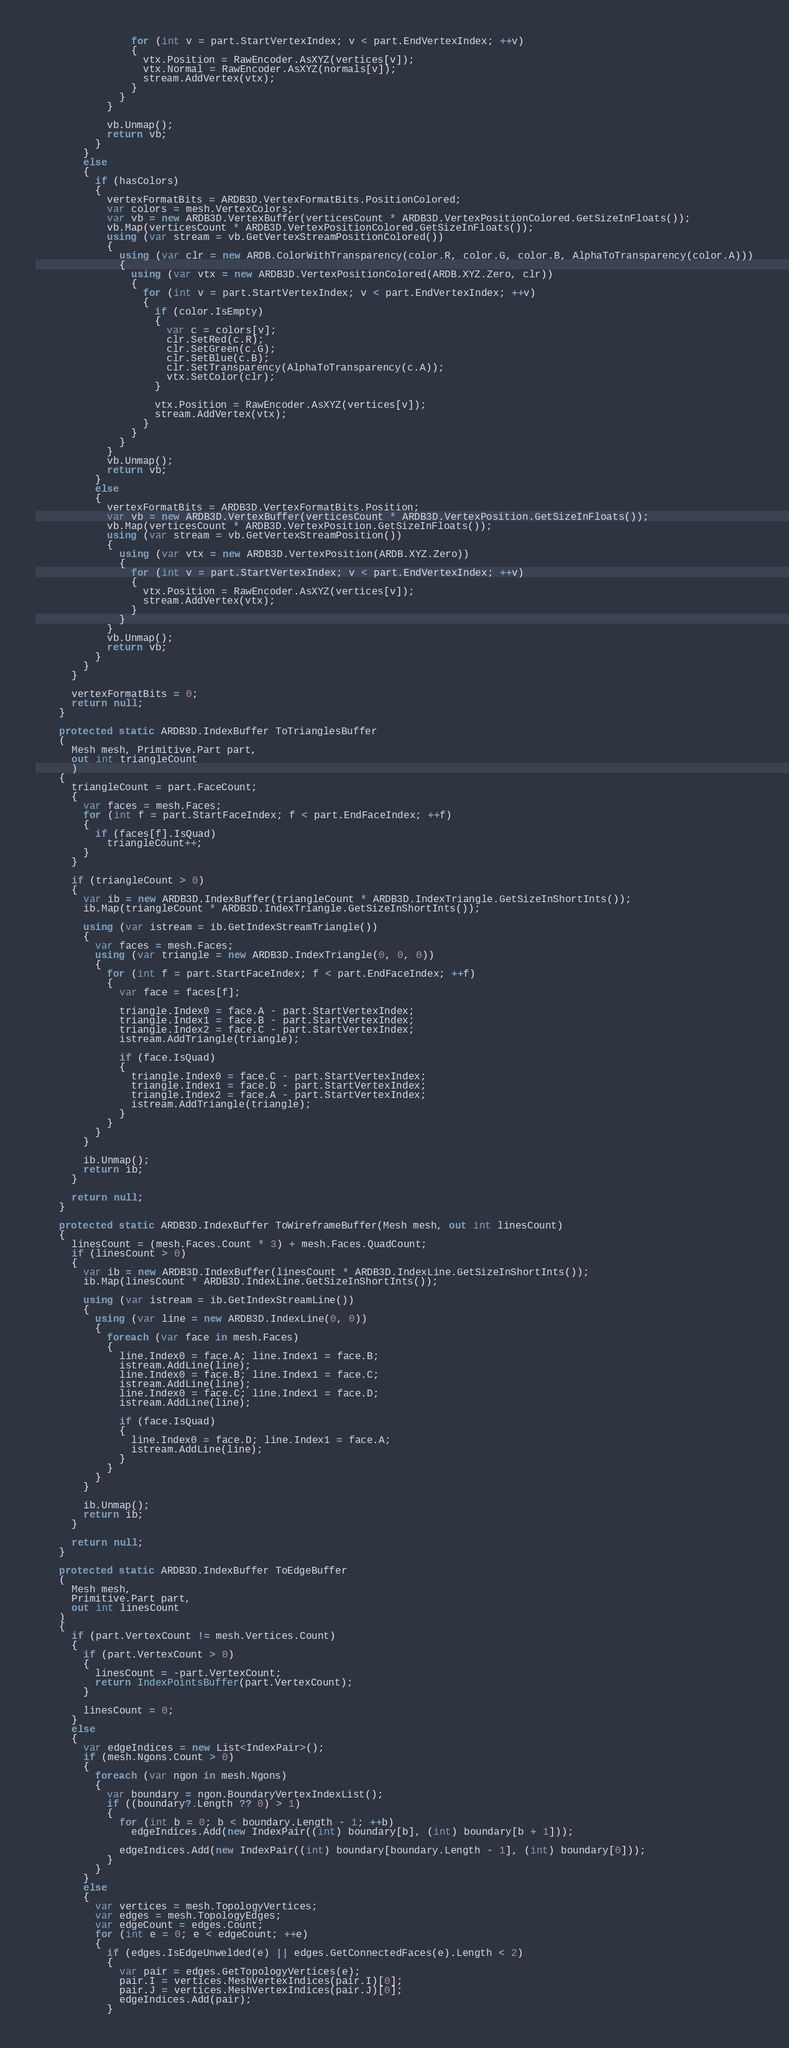<code> <loc_0><loc_0><loc_500><loc_500><_C#_>                for (int v = part.StartVertexIndex; v < part.EndVertexIndex; ++v)
                {
                  vtx.Position = RawEncoder.AsXYZ(vertices[v]);
                  vtx.Normal = RawEncoder.AsXYZ(normals[v]);
                  stream.AddVertex(vtx);
                }
              }
            }

            vb.Unmap();
            return vb;
          }
        }
        else
        {
          if (hasColors)
          {
            vertexFormatBits = ARDB3D.VertexFormatBits.PositionColored;
            var colors = mesh.VertexColors;
            var vb = new ARDB3D.VertexBuffer(verticesCount * ARDB3D.VertexPositionColored.GetSizeInFloats());
            vb.Map(verticesCount * ARDB3D.VertexPositionColored.GetSizeInFloats());
            using (var stream = vb.GetVertexStreamPositionColored())
            {
              using (var clr = new ARDB.ColorWithTransparency(color.R, color.G, color.B, AlphaToTransparency(color.A)))
              {
                using (var vtx = new ARDB3D.VertexPositionColored(ARDB.XYZ.Zero, clr))
                {
                  for (int v = part.StartVertexIndex; v < part.EndVertexIndex; ++v)
                  {
                    if (color.IsEmpty)
                    {
                      var c = colors[v];
                      clr.SetRed(c.R);
                      clr.SetGreen(c.G);
                      clr.SetBlue(c.B);
                      clr.SetTransparency(AlphaToTransparency(c.A));
                      vtx.SetColor(clr);
                    }

                    vtx.Position = RawEncoder.AsXYZ(vertices[v]);
                    stream.AddVertex(vtx);
                  }
                }
              }
            }
            vb.Unmap();
            return vb;
          }
          else
          {
            vertexFormatBits = ARDB3D.VertexFormatBits.Position;
            var vb = new ARDB3D.VertexBuffer(verticesCount * ARDB3D.VertexPosition.GetSizeInFloats());
            vb.Map(verticesCount * ARDB3D.VertexPosition.GetSizeInFloats());
            using (var stream = vb.GetVertexStreamPosition())
            {
              using (var vtx = new ARDB3D.VertexPosition(ARDB.XYZ.Zero))
              {
                for (int v = part.StartVertexIndex; v < part.EndVertexIndex; ++v)
                {
                  vtx.Position = RawEncoder.AsXYZ(vertices[v]);
                  stream.AddVertex(vtx);
                }
              }
            }
            vb.Unmap();
            return vb;
          }
        }
      }

      vertexFormatBits = 0;
      return null;
    }

    protected static ARDB3D.IndexBuffer ToTrianglesBuffer
    (
      Mesh mesh, Primitive.Part part,
      out int triangleCount
      )
    {
      triangleCount = part.FaceCount;
      {
        var faces = mesh.Faces;
        for (int f = part.StartFaceIndex; f < part.EndFaceIndex; ++f)
        {
          if (faces[f].IsQuad)
            triangleCount++;
        }
      }

      if (triangleCount > 0)
      {
        var ib = new ARDB3D.IndexBuffer(triangleCount * ARDB3D.IndexTriangle.GetSizeInShortInts());
        ib.Map(triangleCount * ARDB3D.IndexTriangle.GetSizeInShortInts());

        using (var istream = ib.GetIndexStreamTriangle())
        {
          var faces = mesh.Faces;
          using (var triangle = new ARDB3D.IndexTriangle(0, 0, 0))
          {
            for (int f = part.StartFaceIndex; f < part.EndFaceIndex; ++f)
            {
              var face = faces[f];

              triangle.Index0 = face.A - part.StartVertexIndex;
              triangle.Index1 = face.B - part.StartVertexIndex;
              triangle.Index2 = face.C - part.StartVertexIndex;
              istream.AddTriangle(triangle);

              if (face.IsQuad)
              {
                triangle.Index0 = face.C - part.StartVertexIndex;
                triangle.Index1 = face.D - part.StartVertexIndex;
                triangle.Index2 = face.A - part.StartVertexIndex;
                istream.AddTriangle(triangle);
              }
            }
          }
        }

        ib.Unmap();
        return ib;
      }

      return null;
    }

    protected static ARDB3D.IndexBuffer ToWireframeBuffer(Mesh mesh, out int linesCount)
    {
      linesCount = (mesh.Faces.Count * 3) + mesh.Faces.QuadCount;
      if (linesCount > 0)
      {
        var ib = new ARDB3D.IndexBuffer(linesCount * ARDB3D.IndexLine.GetSizeInShortInts());
        ib.Map(linesCount * ARDB3D.IndexLine.GetSizeInShortInts());

        using (var istream = ib.GetIndexStreamLine())
        {
          using (var line = new ARDB3D.IndexLine(0, 0))
          {
            foreach (var face in mesh.Faces)
            {
              line.Index0 = face.A; line.Index1 = face.B;
              istream.AddLine(line);
              line.Index0 = face.B; line.Index1 = face.C;
              istream.AddLine(line);
              line.Index0 = face.C; line.Index1 = face.D;
              istream.AddLine(line);

              if (face.IsQuad)
              {
                line.Index0 = face.D; line.Index1 = face.A;
                istream.AddLine(line);
              }
            }
          }
        }

        ib.Unmap();
        return ib;
      }

      return null;
    }

    protected static ARDB3D.IndexBuffer ToEdgeBuffer
    (
      Mesh mesh,
      Primitive.Part part,
      out int linesCount
    )
    {
      if (part.VertexCount != mesh.Vertices.Count)
      {
        if (part.VertexCount > 0)
        {
          linesCount = -part.VertexCount;
          return IndexPointsBuffer(part.VertexCount);
        }

        linesCount = 0;
      }
      else
      {
        var edgeIndices = new List<IndexPair>();
        if (mesh.Ngons.Count > 0)
        {
          foreach (var ngon in mesh.Ngons)
          {
            var boundary = ngon.BoundaryVertexIndexList();
            if ((boundary?.Length ?? 0) > 1)
            {
              for (int b = 0; b < boundary.Length - 1; ++b)
                edgeIndices.Add(new IndexPair((int) boundary[b], (int) boundary[b + 1]));

              edgeIndices.Add(new IndexPair((int) boundary[boundary.Length - 1], (int) boundary[0]));
            }
          }
        }
        else
        {
          var vertices = mesh.TopologyVertices;
          var edges = mesh.TopologyEdges;
          var edgeCount = edges.Count;
          for (int e = 0; e < edgeCount; ++e)
          {
            if (edges.IsEdgeUnwelded(e) || edges.GetConnectedFaces(e).Length < 2)
            {
              var pair = edges.GetTopologyVertices(e);
              pair.I = vertices.MeshVertexIndices(pair.I)[0];
              pair.J = vertices.MeshVertexIndices(pair.J)[0];
              edgeIndices.Add(pair);
            }</code> 